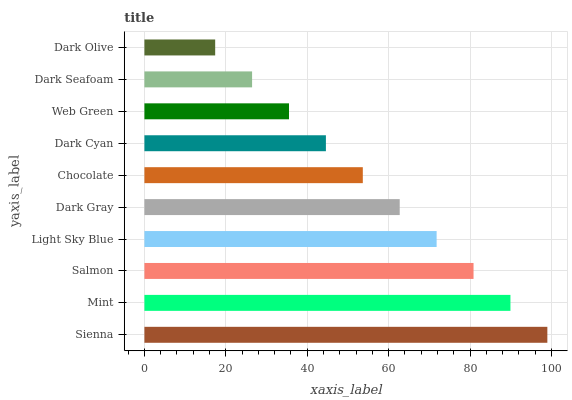Is Dark Olive the minimum?
Answer yes or no. Yes. Is Sienna the maximum?
Answer yes or no. Yes. Is Mint the minimum?
Answer yes or no. No. Is Mint the maximum?
Answer yes or no. No. Is Sienna greater than Mint?
Answer yes or no. Yes. Is Mint less than Sienna?
Answer yes or no. Yes. Is Mint greater than Sienna?
Answer yes or no. No. Is Sienna less than Mint?
Answer yes or no. No. Is Dark Gray the high median?
Answer yes or no. Yes. Is Chocolate the low median?
Answer yes or no. Yes. Is Chocolate the high median?
Answer yes or no. No. Is Mint the low median?
Answer yes or no. No. 